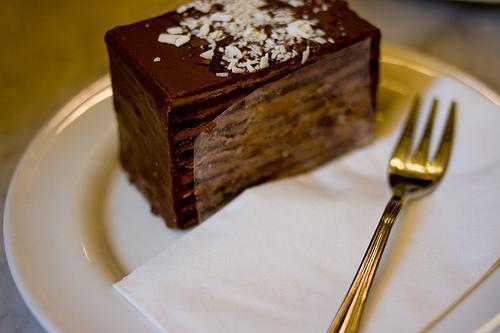How many tines does this fork have?
Give a very brief answer. 3. How many pieces of cake are on the plate?
Give a very brief answer. 1. 